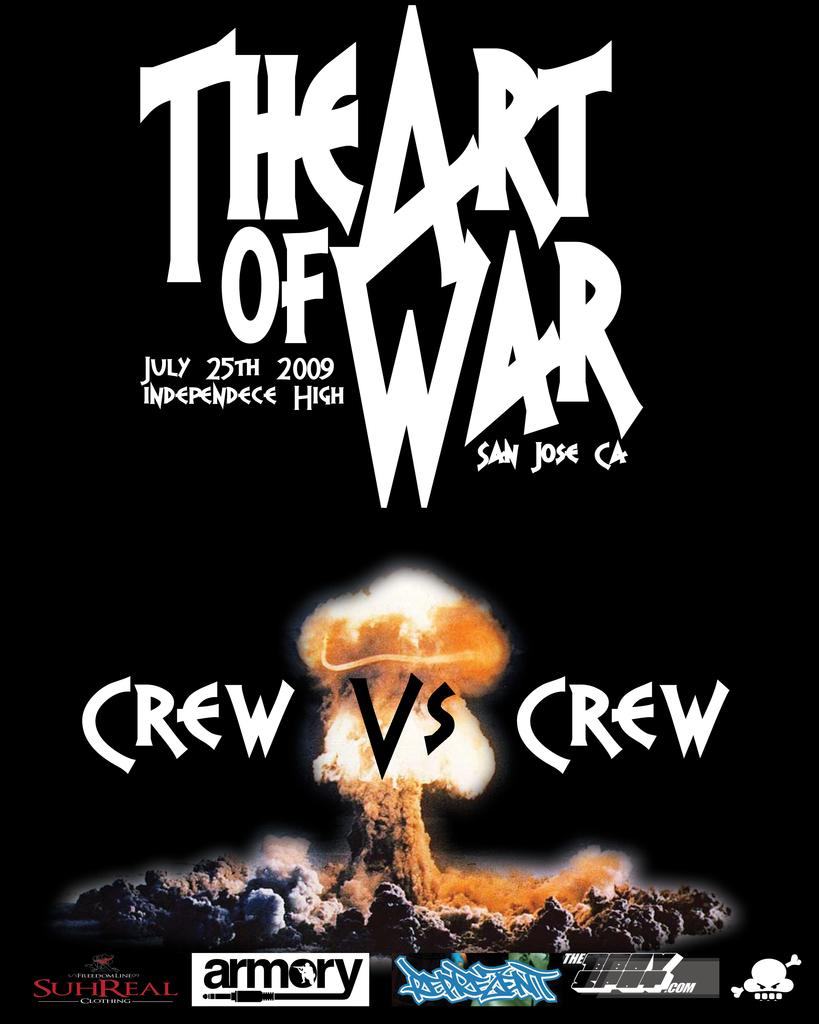<image>
Write a terse but informative summary of the picture. A promotional poster which is advertising The Art of War playing on July 25, 2009. 